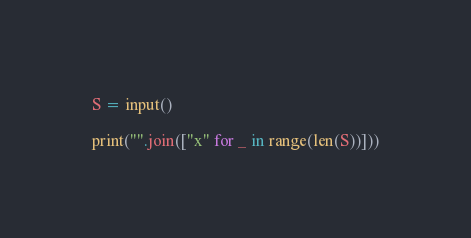Convert code to text. <code><loc_0><loc_0><loc_500><loc_500><_Python_>S = input()

print("".join(["x" for _ in range(len(S))]))</code> 